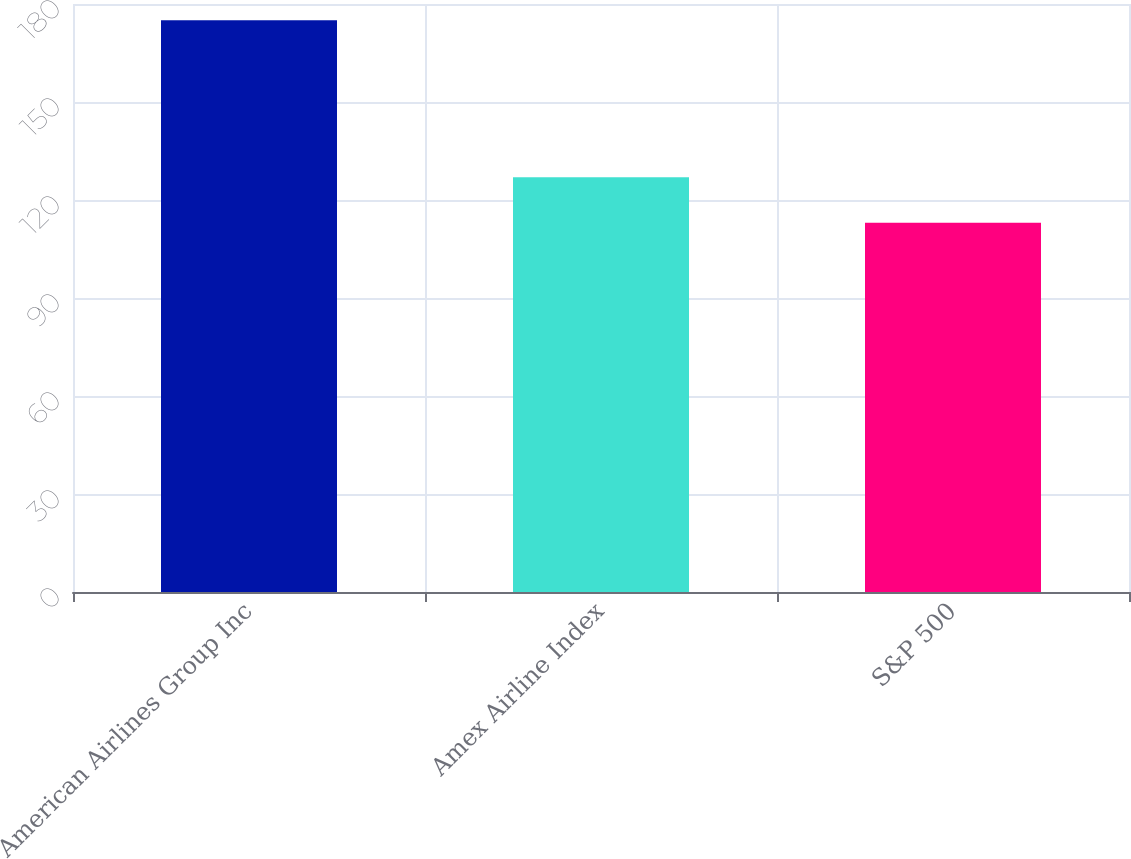<chart> <loc_0><loc_0><loc_500><loc_500><bar_chart><fcel>American Airlines Group Inc<fcel>Amex Airline Index<fcel>S&P 500<nl><fcel>175<fcel>127<fcel>113<nl></chart> 